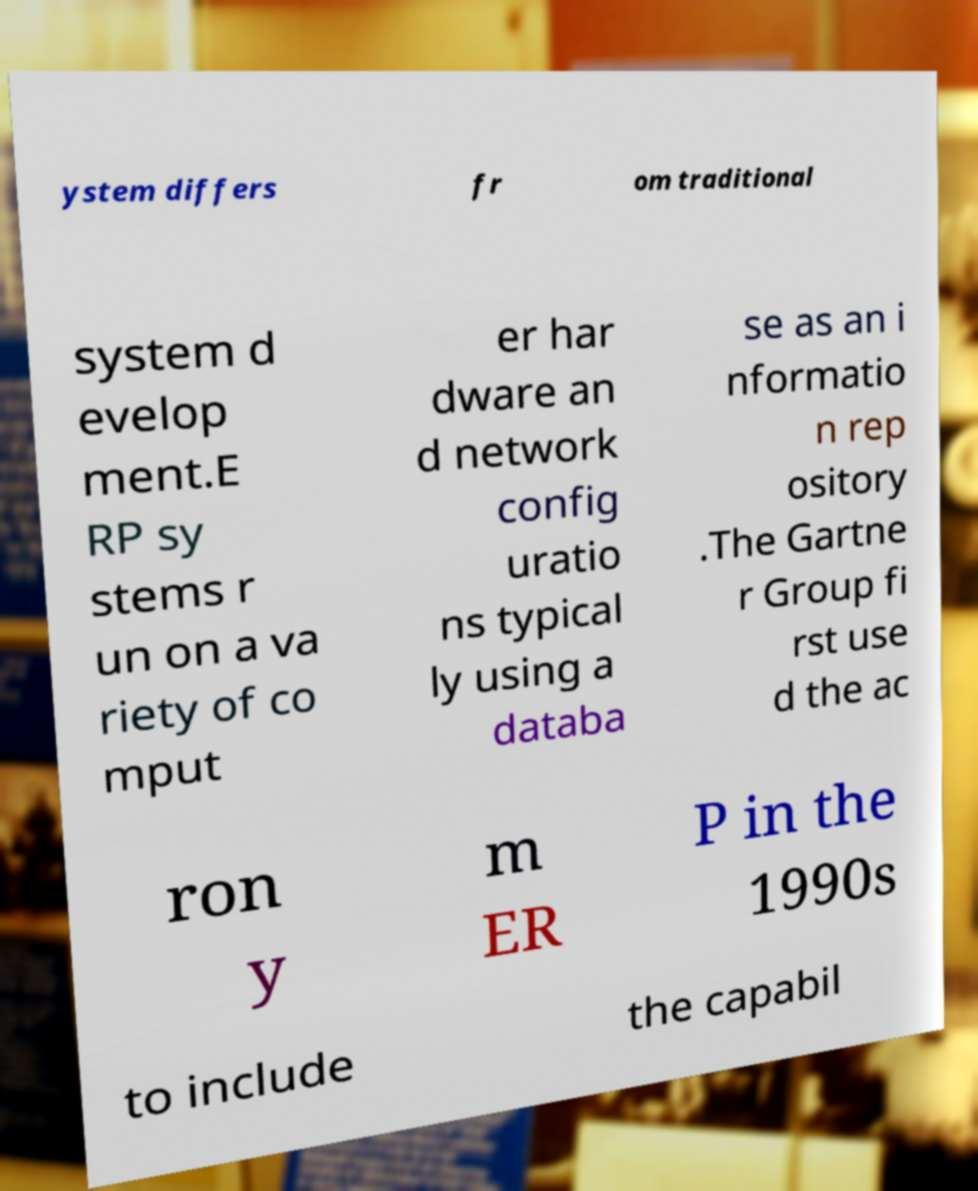Can you accurately transcribe the text from the provided image for me? ystem differs fr om traditional system d evelop ment.E RP sy stems r un on a va riety of co mput er har dware an d network config uratio ns typical ly using a databa se as an i nformatio n rep ository .The Gartne r Group fi rst use d the ac ron y m ER P in the 1990s to include the capabil 